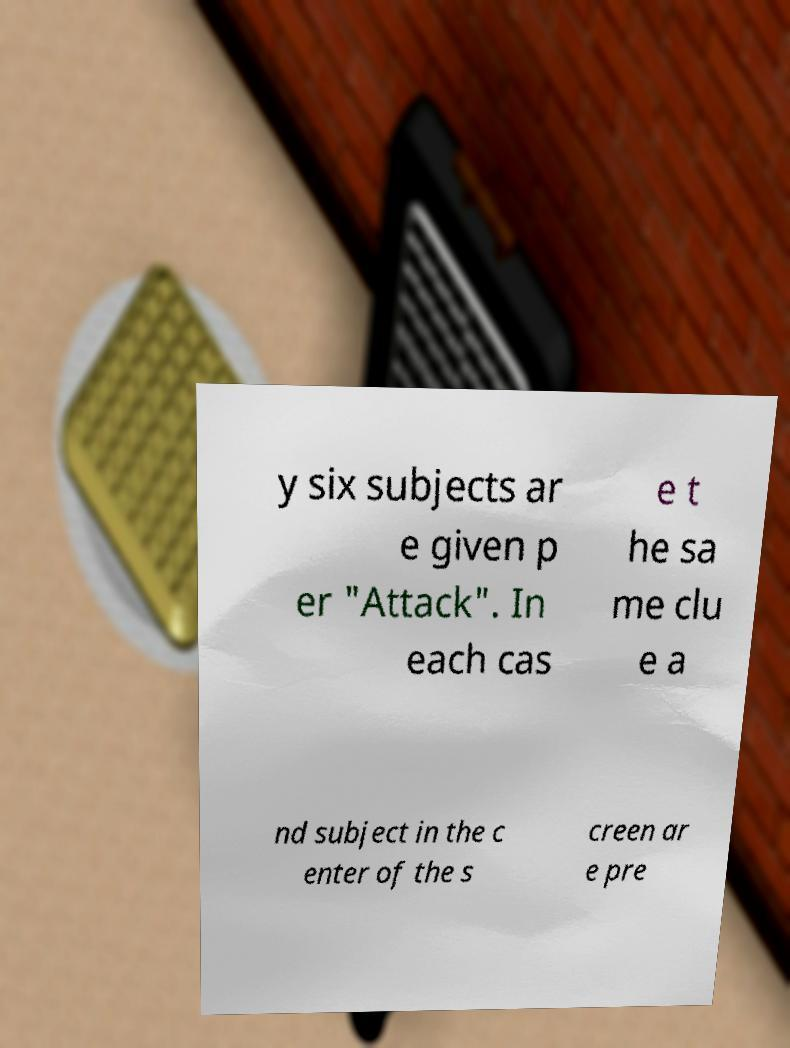Please identify and transcribe the text found in this image. y six subjects ar e given p er "Attack". In each cas e t he sa me clu e a nd subject in the c enter of the s creen ar e pre 